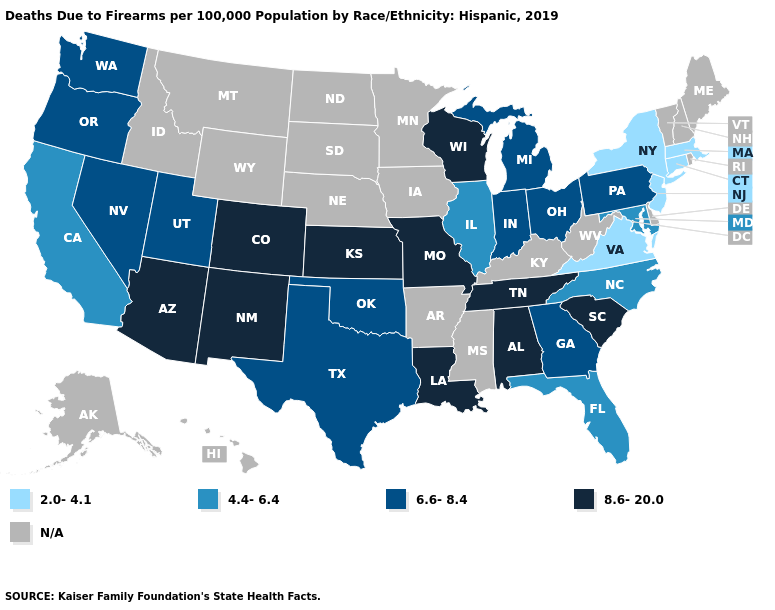What is the value of Wyoming?
Give a very brief answer. N/A. What is the value of Illinois?
Short answer required. 4.4-6.4. Name the states that have a value in the range 4.4-6.4?
Write a very short answer. California, Florida, Illinois, Maryland, North Carolina. Name the states that have a value in the range 6.6-8.4?
Short answer required. Georgia, Indiana, Michigan, Nevada, Ohio, Oklahoma, Oregon, Pennsylvania, Texas, Utah, Washington. Is the legend a continuous bar?
Answer briefly. No. Is the legend a continuous bar?
Concise answer only. No. What is the value of Louisiana?
Keep it brief. 8.6-20.0. What is the value of Montana?
Keep it brief. N/A. Among the states that border Tennessee , which have the lowest value?
Concise answer only. Virginia. Name the states that have a value in the range 6.6-8.4?
Short answer required. Georgia, Indiana, Michigan, Nevada, Ohio, Oklahoma, Oregon, Pennsylvania, Texas, Utah, Washington. Name the states that have a value in the range 8.6-20.0?
Answer briefly. Alabama, Arizona, Colorado, Kansas, Louisiana, Missouri, New Mexico, South Carolina, Tennessee, Wisconsin. What is the highest value in the USA?
Concise answer only. 8.6-20.0. Among the states that border Michigan , does Wisconsin have the lowest value?
Quick response, please. No. 